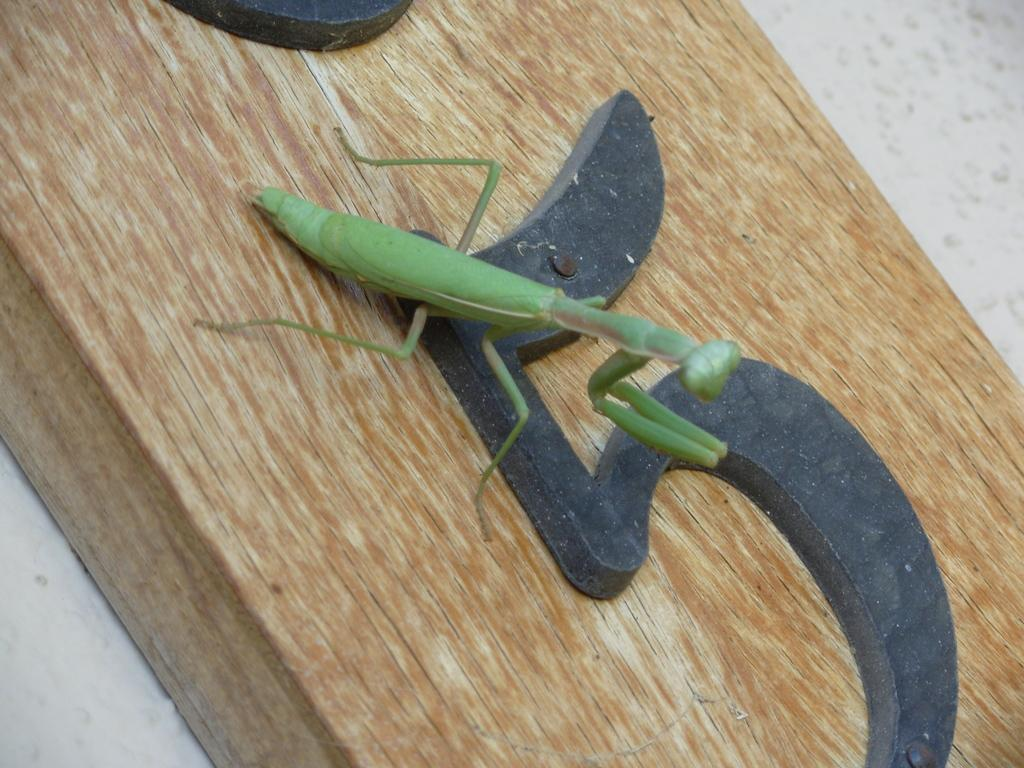What type of insect is in the image? There is a grasshopper in the image. What surface is the grasshopper on? The grasshopper is on a wooden surface. What else can be seen in the image besides the grasshopper? There is text visible in the image. How many trucks are visible in the image? There are no trucks present in the image. Is the grasshopper caught in a net in the image? There is no net visible in the image, and the grasshopper is not shown to be caught in one. 